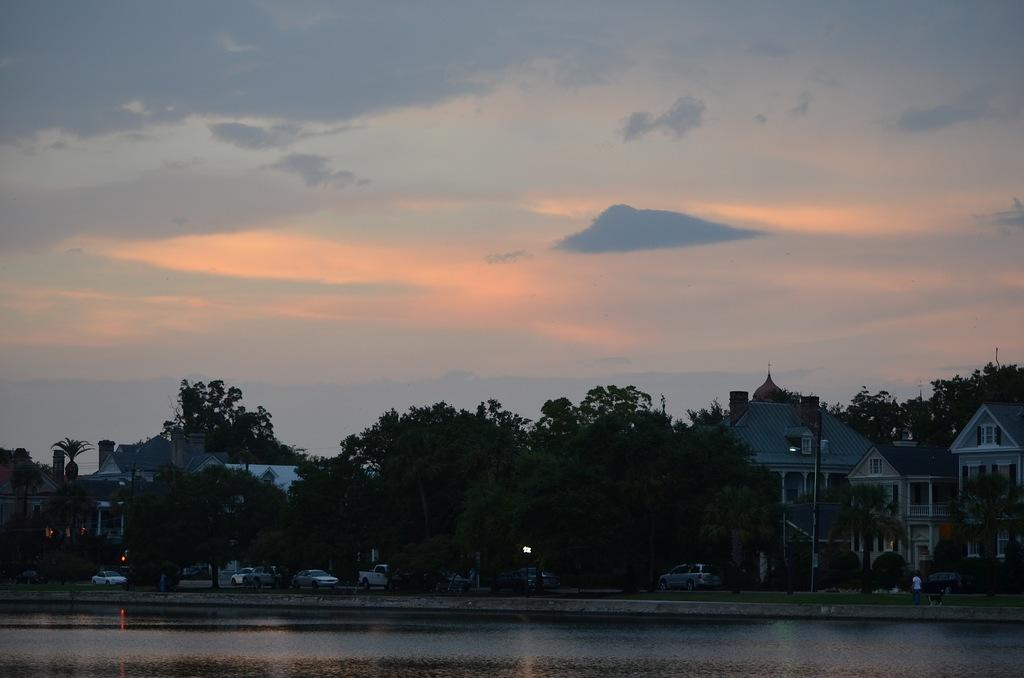What is the main object in the center of the image? There is an object in the center of the image that is shining. What can be seen in the background of the image? In the background of the image, there are cars, grass, trees, and buildings. How would you describe the weather in the image? The sky is cloudy in the image, suggesting a potentially overcast or rainy day. How many screws can be seen holding the twig in place in the image? There is no twig or screws present in the image. What type of boats can be seen in the harbor in the image? There is no harbor or boats present in the image. 